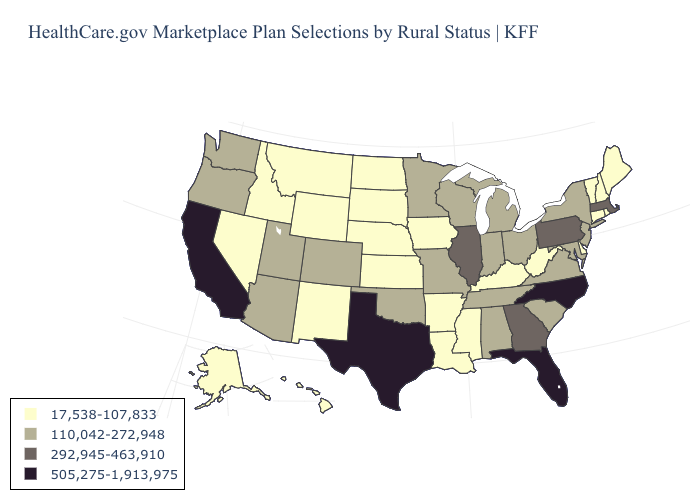What is the highest value in the USA?
Give a very brief answer. 505,275-1,913,975. What is the value of Minnesota?
Short answer required. 110,042-272,948. Does North Carolina have the highest value in the USA?
Quick response, please. Yes. Does Virginia have the highest value in the USA?
Give a very brief answer. No. Does New York have the same value as New Jersey?
Be succinct. Yes. What is the value of Maryland?
Keep it brief. 110,042-272,948. Name the states that have a value in the range 17,538-107,833?
Be succinct. Alaska, Arkansas, Connecticut, Delaware, Hawaii, Idaho, Iowa, Kansas, Kentucky, Louisiana, Maine, Mississippi, Montana, Nebraska, Nevada, New Hampshire, New Mexico, North Dakota, Rhode Island, South Dakota, Vermont, West Virginia, Wyoming. Name the states that have a value in the range 505,275-1,913,975?
Write a very short answer. California, Florida, North Carolina, Texas. What is the lowest value in states that border South Carolina?
Concise answer only. 292,945-463,910. Name the states that have a value in the range 110,042-272,948?
Answer briefly. Alabama, Arizona, Colorado, Indiana, Maryland, Michigan, Minnesota, Missouri, New Jersey, New York, Ohio, Oklahoma, Oregon, South Carolina, Tennessee, Utah, Virginia, Washington, Wisconsin. What is the highest value in the USA?
Keep it brief. 505,275-1,913,975. What is the value of Tennessee?
Give a very brief answer. 110,042-272,948. What is the value of Hawaii?
Be succinct. 17,538-107,833. Does North Carolina have the highest value in the USA?
Write a very short answer. Yes. 